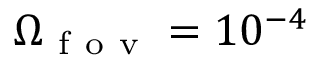Convert formula to latex. <formula><loc_0><loc_0><loc_500><loc_500>\Omega _ { f o v } = 1 0 ^ { - 4 }</formula> 